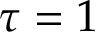Convert formula to latex. <formula><loc_0><loc_0><loc_500><loc_500>\tau = 1</formula> 